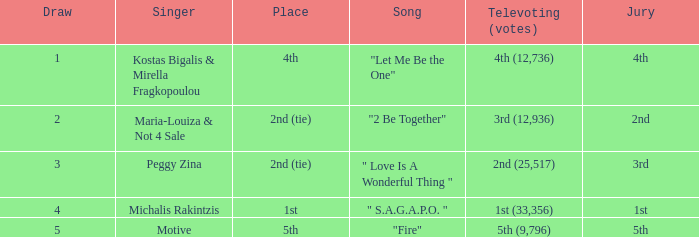What song was 2nd (25,517) in televoting (votes)? " Love Is A Wonderful Thing ". 